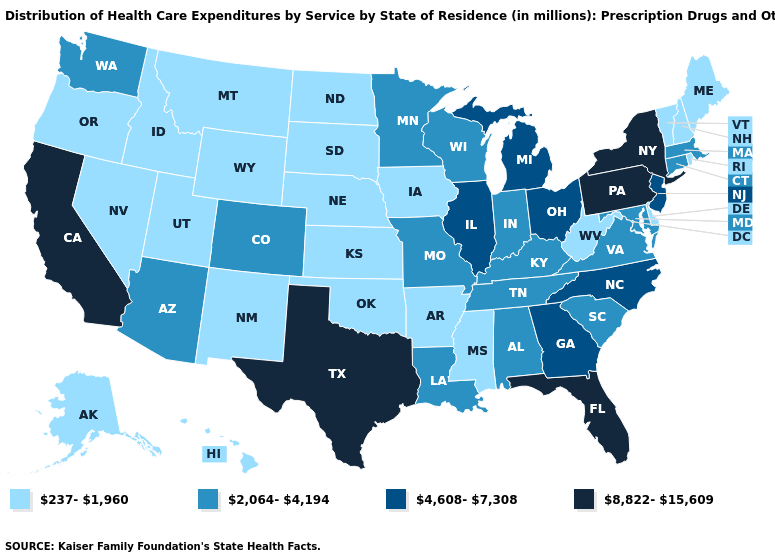Which states hav the highest value in the West?
Give a very brief answer. California. Name the states that have a value in the range 2,064-4,194?
Keep it brief. Alabama, Arizona, Colorado, Connecticut, Indiana, Kentucky, Louisiana, Maryland, Massachusetts, Minnesota, Missouri, South Carolina, Tennessee, Virginia, Washington, Wisconsin. How many symbols are there in the legend?
Answer briefly. 4. What is the value of Alabama?
Answer briefly. 2,064-4,194. Name the states that have a value in the range 8,822-15,609?
Give a very brief answer. California, Florida, New York, Pennsylvania, Texas. Does Idaho have the same value as South Carolina?
Concise answer only. No. Does Hawaii have the same value as Nevada?
Answer briefly. Yes. Does North Carolina have the same value as Illinois?
Give a very brief answer. Yes. Among the states that border Mississippi , does Tennessee have the lowest value?
Give a very brief answer. No. Does Ohio have a lower value than Missouri?
Keep it brief. No. Does the map have missing data?
Short answer required. No. What is the lowest value in the USA?
Answer briefly. 237-1,960. What is the value of West Virginia?
Write a very short answer. 237-1,960. What is the value of Mississippi?
Short answer required. 237-1,960. Which states have the lowest value in the USA?
Quick response, please. Alaska, Arkansas, Delaware, Hawaii, Idaho, Iowa, Kansas, Maine, Mississippi, Montana, Nebraska, Nevada, New Hampshire, New Mexico, North Dakota, Oklahoma, Oregon, Rhode Island, South Dakota, Utah, Vermont, West Virginia, Wyoming. 